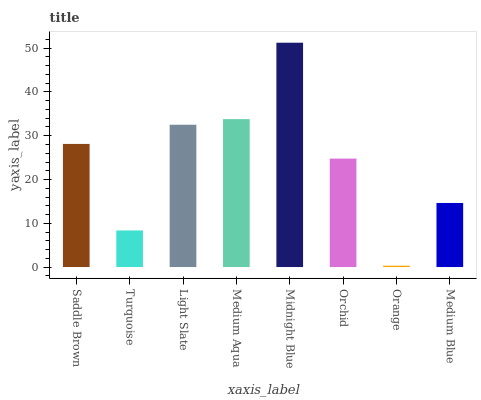Is Orange the minimum?
Answer yes or no. Yes. Is Midnight Blue the maximum?
Answer yes or no. Yes. Is Turquoise the minimum?
Answer yes or no. No. Is Turquoise the maximum?
Answer yes or no. No. Is Saddle Brown greater than Turquoise?
Answer yes or no. Yes. Is Turquoise less than Saddle Brown?
Answer yes or no. Yes. Is Turquoise greater than Saddle Brown?
Answer yes or no. No. Is Saddle Brown less than Turquoise?
Answer yes or no. No. Is Saddle Brown the high median?
Answer yes or no. Yes. Is Orchid the low median?
Answer yes or no. Yes. Is Light Slate the high median?
Answer yes or no. No. Is Medium Blue the low median?
Answer yes or no. No. 